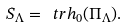Convert formula to latex. <formula><loc_0><loc_0><loc_500><loc_500>S _ { \Lambda } = \ t r h _ { 0 } ( \Pi _ { \Lambda } ) .</formula> 